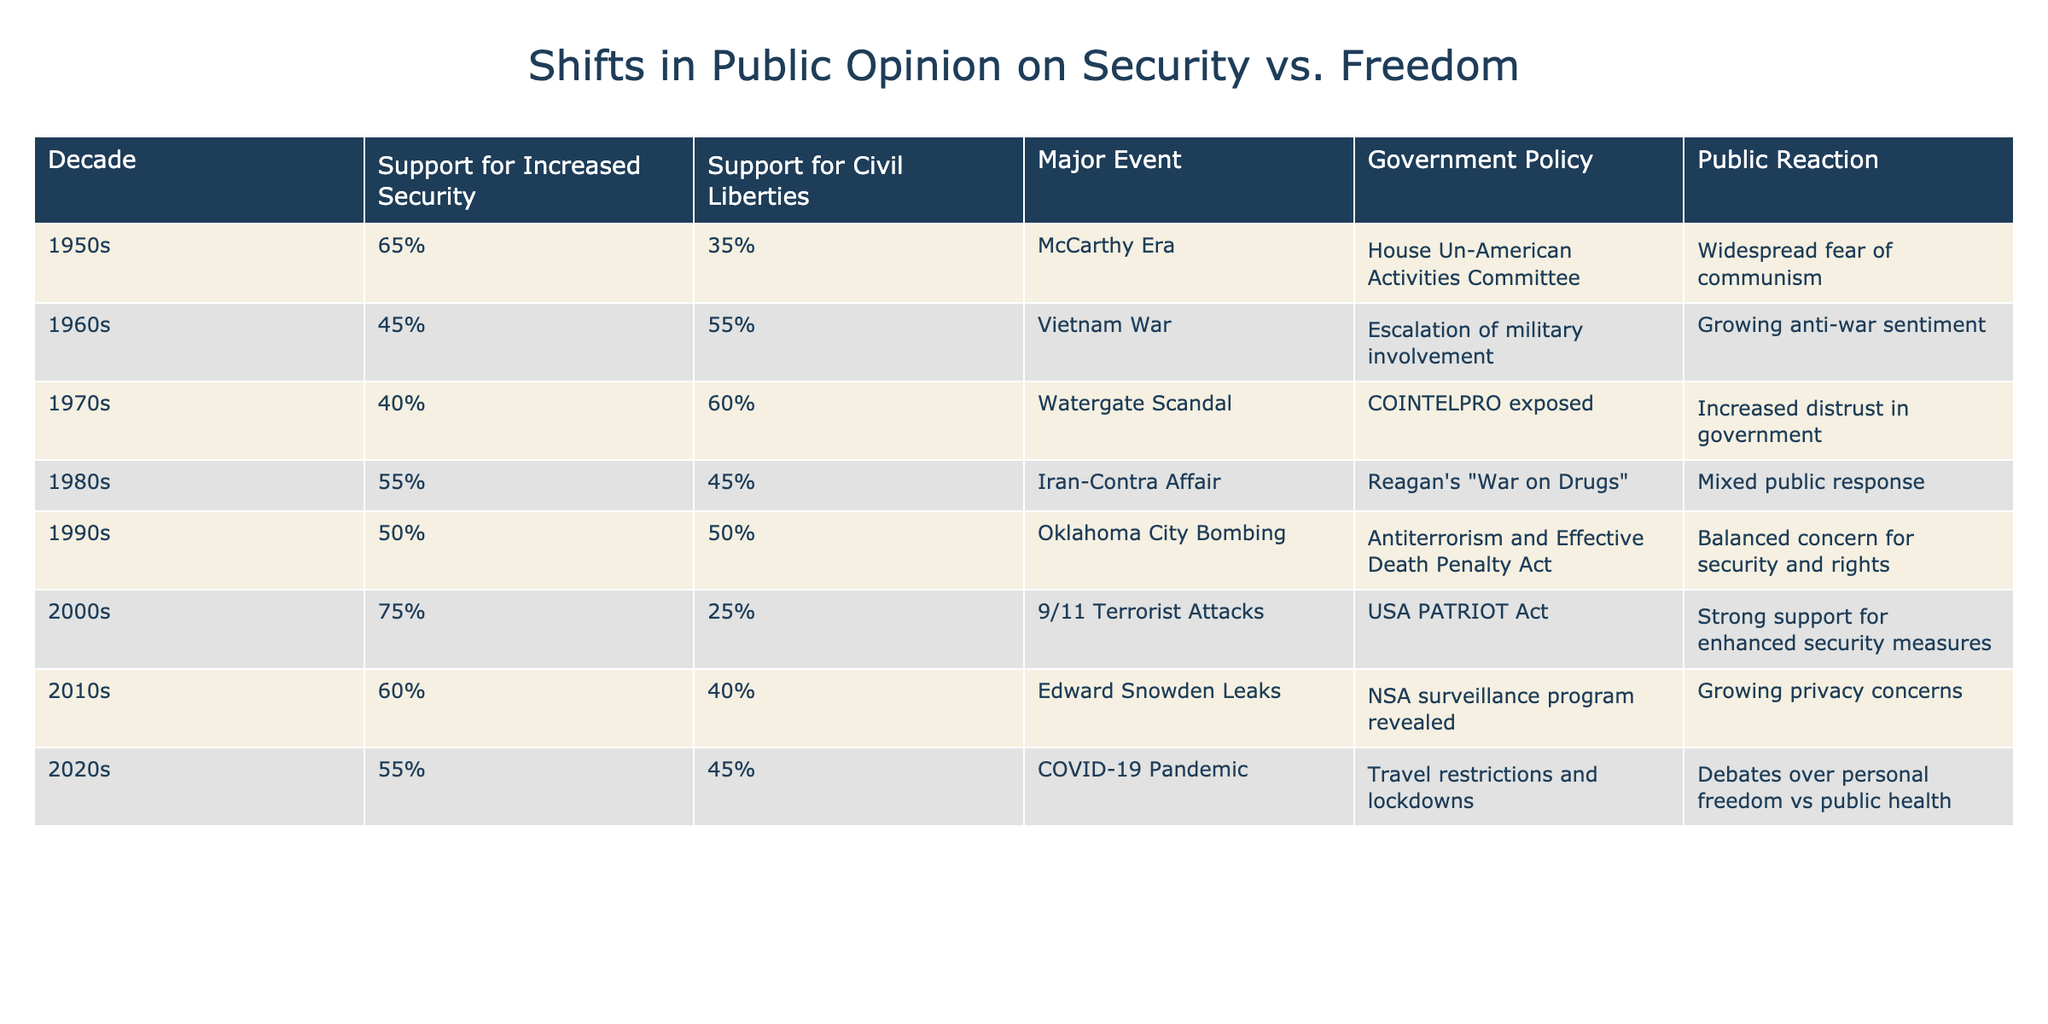What was the support for increased security in the 1980s? According to the table, the support for increased security in the 1980s is listed as 55%.
Answer: 55% How did support for civil liberties change from the 1950s to the 2010s? In the 1950s, support for civil liberties was 35%, and by the 2010s, it increased to 40%. This is a change of 5 percentage points.
Answer: Increased by 5 percentage points Was there greater support for increased security or civil liberties in the 1970s? In the 1970s, support for increased security was 40%, while support for civil liberties was 60%. Therefore, there was greater support for civil liberties.
Answer: Greater support for civil liberties Which decade had the highest support for increased security? The data shows that the highest support for increased security was in the 2000s, at 75%.
Answer: 2000s had the highest support What are the average support levels for increased security and civil liberties across all decades? To find the average support for increased security, add all support percentages (65 + 45 + 40 + 55 + 50 + 75 + 60 + 55) and divide by 8. This equals 52.5. For civil liberties, do the same (35 + 55 + 60 + 45 + 50 + 25 + 40 + 45), which equals 45.
Answer: Average support: Increased security 52.5%, Civil liberties 45% Did the public reaction to the Vietnam War indicate a shift in opinion towards civil liberties? Yes, the public reaction to the Vietnam War was characterized by growing anti-war sentiment, which often correlates with increased support for civil liberties, moving from 45% support for increased security to 55% for civil liberties.
Answer: Yes In which decade did support for civil liberties first surpass that for increased security? In the 1960s, support for civil liberties (55%) first surpassed that for increased security (45%).
Answer: 1960s Was the public reaction to the 9/11 attacks overwhelmingly positive toward enhanced security measures? Yes, the public reaction was indicated as strong support for enhanced security measures following the 9/11 attacks.
Answer: Yes 